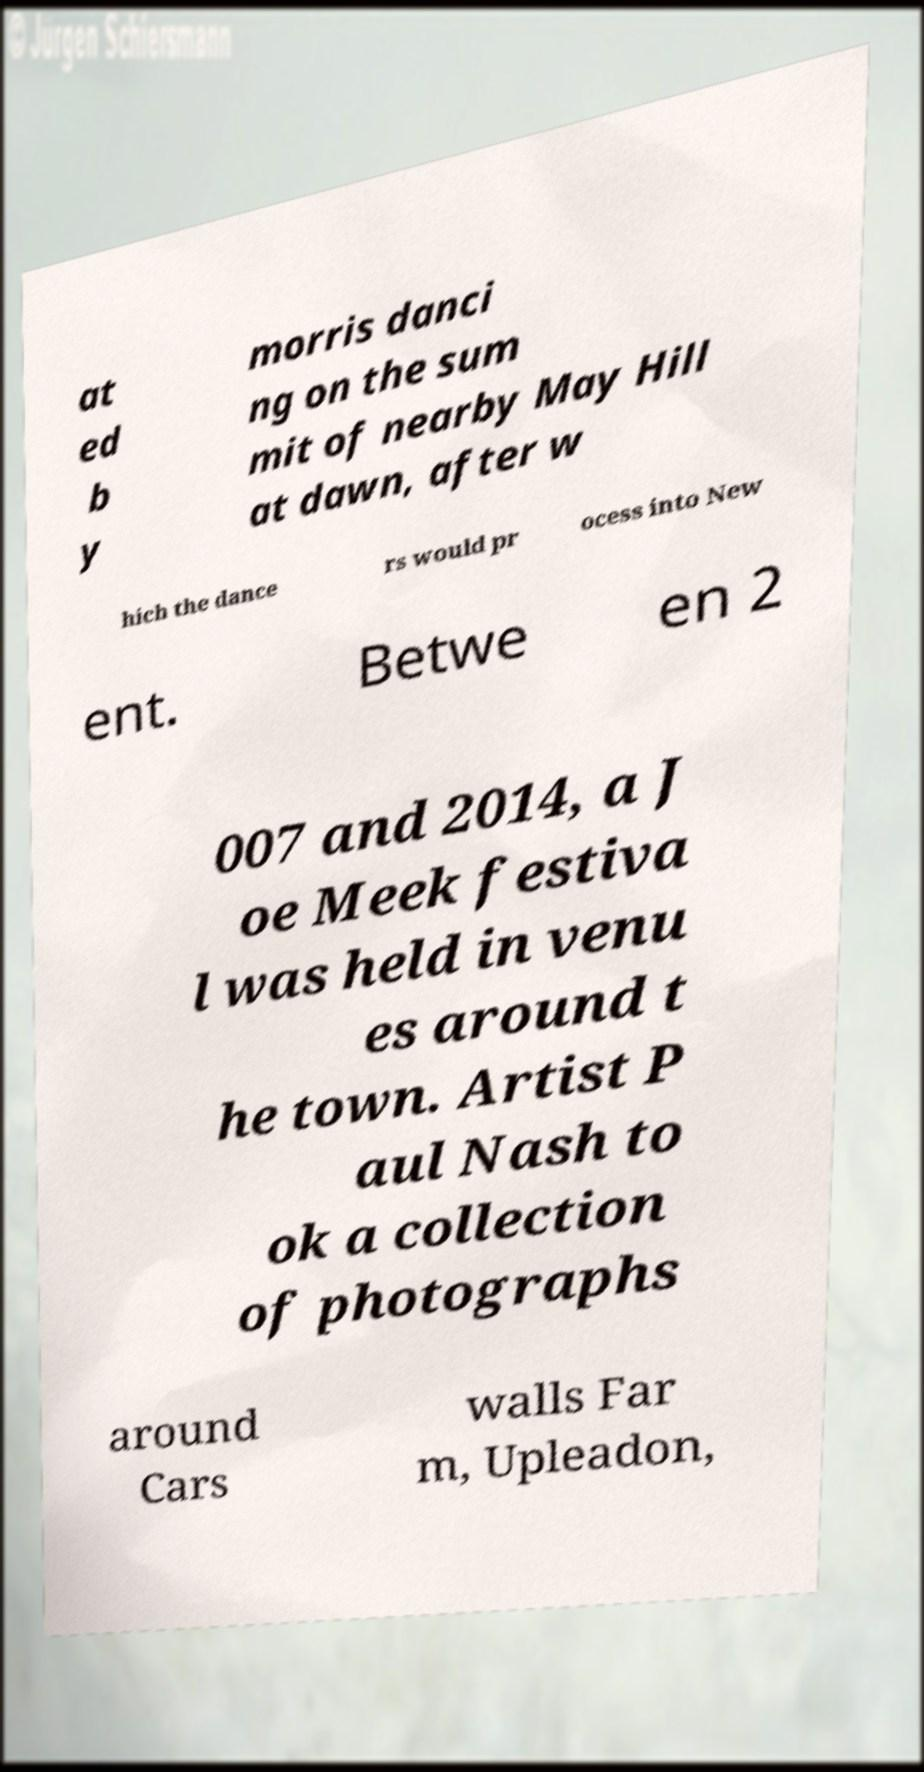For documentation purposes, I need the text within this image transcribed. Could you provide that? at ed b y morris danci ng on the sum mit of nearby May Hill at dawn, after w hich the dance rs would pr ocess into New ent. Betwe en 2 007 and 2014, a J oe Meek festiva l was held in venu es around t he town. Artist P aul Nash to ok a collection of photographs around Cars walls Far m, Upleadon, 